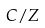Convert formula to latex. <formula><loc_0><loc_0><loc_500><loc_500>C / Z</formula> 